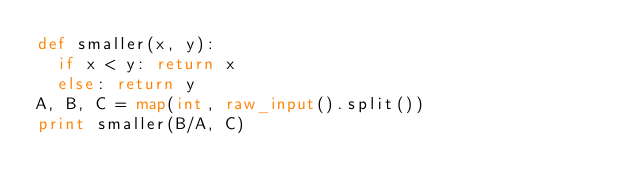<code> <loc_0><loc_0><loc_500><loc_500><_Python_>def smaller(x, y):
	if x < y: return x
	else: return y
A, B, C = map(int, raw_input().split())
print smaller(B/A, C)</code> 